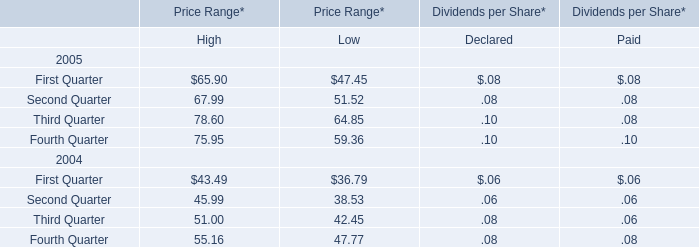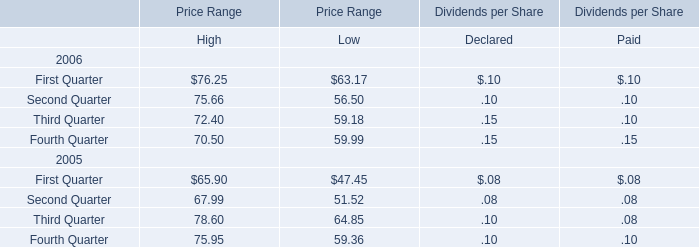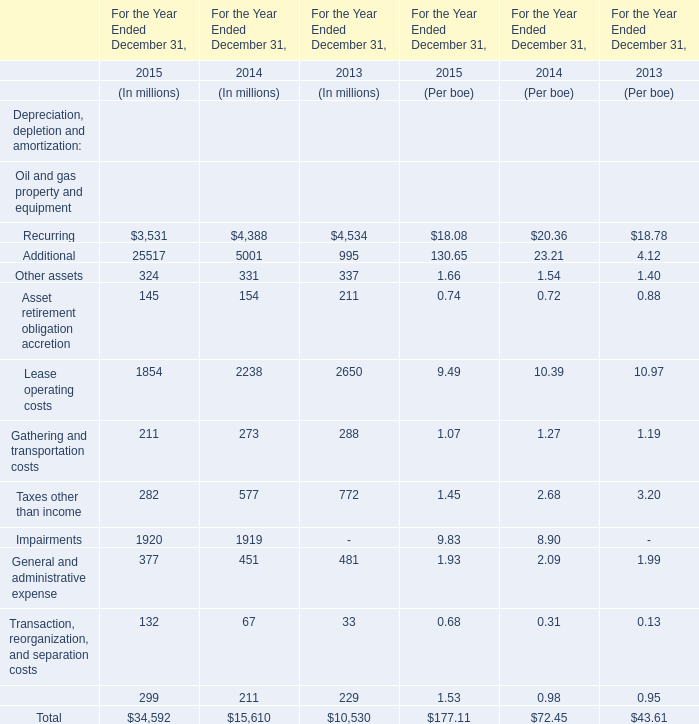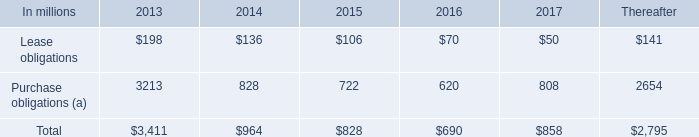what was the change in rent expenses between 2010 and 2011? 
Computations: (205 - 210)
Answer: -5.0. 